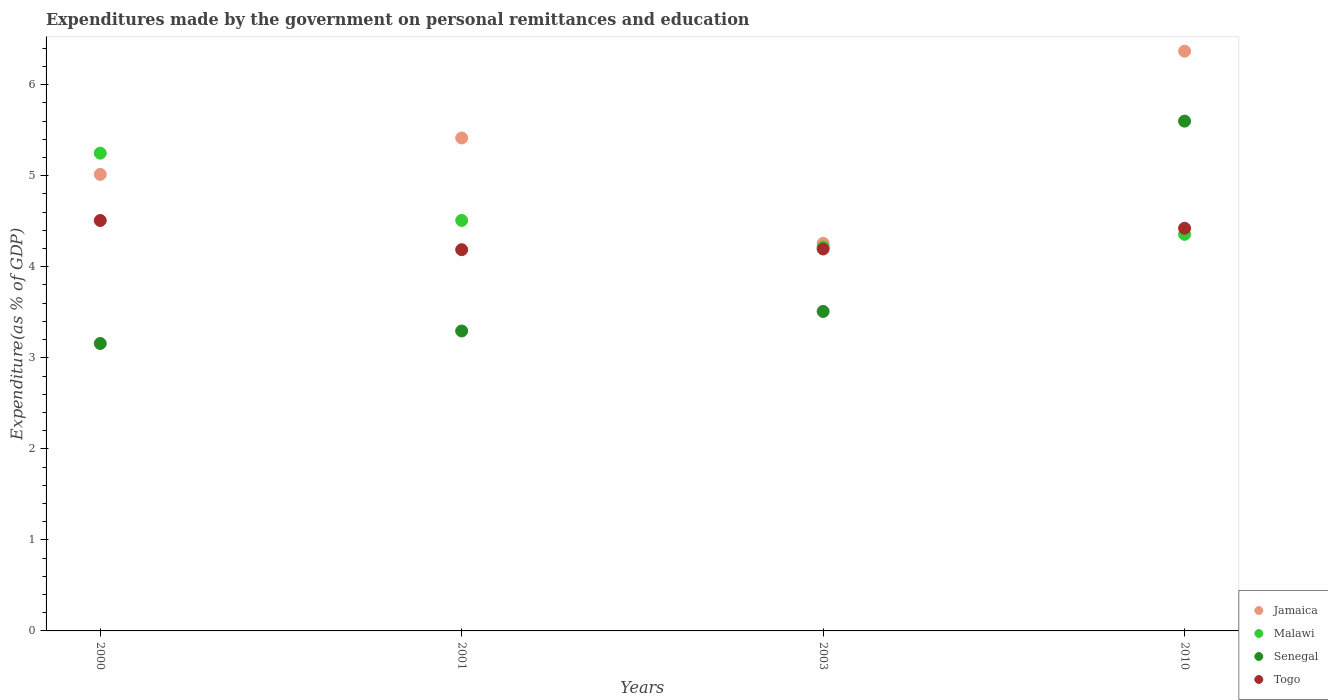What is the expenditures made by the government on personal remittances and education in Togo in 2001?
Make the answer very short. 4.19. Across all years, what is the maximum expenditures made by the government on personal remittances and education in Togo?
Provide a succinct answer. 4.51. Across all years, what is the minimum expenditures made by the government on personal remittances and education in Togo?
Offer a very short reply. 4.19. What is the total expenditures made by the government on personal remittances and education in Senegal in the graph?
Provide a succinct answer. 15.56. What is the difference between the expenditures made by the government on personal remittances and education in Jamaica in 2000 and that in 2010?
Keep it short and to the point. -1.35. What is the difference between the expenditures made by the government on personal remittances and education in Malawi in 2001 and the expenditures made by the government on personal remittances and education in Senegal in 2010?
Make the answer very short. -1.09. What is the average expenditures made by the government on personal remittances and education in Malawi per year?
Your response must be concise. 4.58. In the year 2000, what is the difference between the expenditures made by the government on personal remittances and education in Jamaica and expenditures made by the government on personal remittances and education in Togo?
Offer a very short reply. 0.51. In how many years, is the expenditures made by the government on personal remittances and education in Malawi greater than 2.6 %?
Make the answer very short. 4. What is the ratio of the expenditures made by the government on personal remittances and education in Jamaica in 2003 to that in 2010?
Your answer should be very brief. 0.67. What is the difference between the highest and the second highest expenditures made by the government on personal remittances and education in Senegal?
Give a very brief answer. 2.09. What is the difference between the highest and the lowest expenditures made by the government on personal remittances and education in Malawi?
Offer a terse response. 1.03. Is the sum of the expenditures made by the government on personal remittances and education in Jamaica in 2003 and 2010 greater than the maximum expenditures made by the government on personal remittances and education in Malawi across all years?
Your answer should be very brief. Yes. Is it the case that in every year, the sum of the expenditures made by the government on personal remittances and education in Togo and expenditures made by the government on personal remittances and education in Senegal  is greater than the sum of expenditures made by the government on personal remittances and education in Jamaica and expenditures made by the government on personal remittances and education in Malawi?
Make the answer very short. No. Is it the case that in every year, the sum of the expenditures made by the government on personal remittances and education in Senegal and expenditures made by the government on personal remittances and education in Togo  is greater than the expenditures made by the government on personal remittances and education in Malawi?
Give a very brief answer. Yes. Does the expenditures made by the government on personal remittances and education in Senegal monotonically increase over the years?
Your answer should be very brief. Yes. Is the expenditures made by the government on personal remittances and education in Togo strictly greater than the expenditures made by the government on personal remittances and education in Jamaica over the years?
Keep it short and to the point. No. Is the expenditures made by the government on personal remittances and education in Senegal strictly less than the expenditures made by the government on personal remittances and education in Togo over the years?
Provide a short and direct response. No. How many years are there in the graph?
Make the answer very short. 4. What is the difference between two consecutive major ticks on the Y-axis?
Make the answer very short. 1. Does the graph contain any zero values?
Give a very brief answer. No. Does the graph contain grids?
Your answer should be very brief. No. Where does the legend appear in the graph?
Ensure brevity in your answer.  Bottom right. How many legend labels are there?
Ensure brevity in your answer.  4. How are the legend labels stacked?
Provide a short and direct response. Vertical. What is the title of the graph?
Provide a succinct answer. Expenditures made by the government on personal remittances and education. Does "High income" appear as one of the legend labels in the graph?
Make the answer very short. No. What is the label or title of the Y-axis?
Give a very brief answer. Expenditure(as % of GDP). What is the Expenditure(as % of GDP) of Jamaica in 2000?
Keep it short and to the point. 5.02. What is the Expenditure(as % of GDP) in Malawi in 2000?
Your answer should be compact. 5.25. What is the Expenditure(as % of GDP) of Senegal in 2000?
Keep it short and to the point. 3.16. What is the Expenditure(as % of GDP) of Togo in 2000?
Offer a terse response. 4.51. What is the Expenditure(as % of GDP) in Jamaica in 2001?
Keep it short and to the point. 5.41. What is the Expenditure(as % of GDP) of Malawi in 2001?
Provide a short and direct response. 4.51. What is the Expenditure(as % of GDP) in Senegal in 2001?
Give a very brief answer. 3.29. What is the Expenditure(as % of GDP) of Togo in 2001?
Offer a terse response. 4.19. What is the Expenditure(as % of GDP) in Jamaica in 2003?
Your answer should be very brief. 4.26. What is the Expenditure(as % of GDP) in Malawi in 2003?
Provide a succinct answer. 4.22. What is the Expenditure(as % of GDP) in Senegal in 2003?
Provide a short and direct response. 3.51. What is the Expenditure(as % of GDP) of Togo in 2003?
Keep it short and to the point. 4.2. What is the Expenditure(as % of GDP) of Jamaica in 2010?
Your answer should be compact. 6.37. What is the Expenditure(as % of GDP) in Malawi in 2010?
Provide a short and direct response. 4.36. What is the Expenditure(as % of GDP) of Senegal in 2010?
Make the answer very short. 5.6. What is the Expenditure(as % of GDP) of Togo in 2010?
Provide a short and direct response. 4.42. Across all years, what is the maximum Expenditure(as % of GDP) of Jamaica?
Provide a short and direct response. 6.37. Across all years, what is the maximum Expenditure(as % of GDP) in Malawi?
Offer a terse response. 5.25. Across all years, what is the maximum Expenditure(as % of GDP) in Senegal?
Your answer should be very brief. 5.6. Across all years, what is the maximum Expenditure(as % of GDP) in Togo?
Make the answer very short. 4.51. Across all years, what is the minimum Expenditure(as % of GDP) in Jamaica?
Make the answer very short. 4.26. Across all years, what is the minimum Expenditure(as % of GDP) of Malawi?
Your answer should be very brief. 4.22. Across all years, what is the minimum Expenditure(as % of GDP) in Senegal?
Your answer should be compact. 3.16. Across all years, what is the minimum Expenditure(as % of GDP) in Togo?
Your answer should be compact. 4.19. What is the total Expenditure(as % of GDP) of Jamaica in the graph?
Your response must be concise. 21.05. What is the total Expenditure(as % of GDP) in Malawi in the graph?
Your answer should be very brief. 18.33. What is the total Expenditure(as % of GDP) in Senegal in the graph?
Offer a very short reply. 15.56. What is the total Expenditure(as % of GDP) in Togo in the graph?
Provide a succinct answer. 17.31. What is the difference between the Expenditure(as % of GDP) of Jamaica in 2000 and that in 2001?
Ensure brevity in your answer.  -0.4. What is the difference between the Expenditure(as % of GDP) of Malawi in 2000 and that in 2001?
Your response must be concise. 0.74. What is the difference between the Expenditure(as % of GDP) of Senegal in 2000 and that in 2001?
Keep it short and to the point. -0.14. What is the difference between the Expenditure(as % of GDP) of Togo in 2000 and that in 2001?
Offer a very short reply. 0.32. What is the difference between the Expenditure(as % of GDP) in Jamaica in 2000 and that in 2003?
Your response must be concise. 0.76. What is the difference between the Expenditure(as % of GDP) of Malawi in 2000 and that in 2003?
Offer a very short reply. 1.03. What is the difference between the Expenditure(as % of GDP) of Senegal in 2000 and that in 2003?
Your answer should be compact. -0.35. What is the difference between the Expenditure(as % of GDP) in Togo in 2000 and that in 2003?
Offer a terse response. 0.31. What is the difference between the Expenditure(as % of GDP) of Jamaica in 2000 and that in 2010?
Provide a succinct answer. -1.35. What is the difference between the Expenditure(as % of GDP) in Malawi in 2000 and that in 2010?
Provide a succinct answer. 0.89. What is the difference between the Expenditure(as % of GDP) of Senegal in 2000 and that in 2010?
Give a very brief answer. -2.44. What is the difference between the Expenditure(as % of GDP) of Togo in 2000 and that in 2010?
Ensure brevity in your answer.  0.09. What is the difference between the Expenditure(as % of GDP) in Jamaica in 2001 and that in 2003?
Give a very brief answer. 1.16. What is the difference between the Expenditure(as % of GDP) of Malawi in 2001 and that in 2003?
Offer a very short reply. 0.29. What is the difference between the Expenditure(as % of GDP) in Senegal in 2001 and that in 2003?
Keep it short and to the point. -0.21. What is the difference between the Expenditure(as % of GDP) of Togo in 2001 and that in 2003?
Your response must be concise. -0.01. What is the difference between the Expenditure(as % of GDP) of Jamaica in 2001 and that in 2010?
Provide a succinct answer. -0.95. What is the difference between the Expenditure(as % of GDP) in Malawi in 2001 and that in 2010?
Provide a succinct answer. 0.15. What is the difference between the Expenditure(as % of GDP) of Senegal in 2001 and that in 2010?
Offer a terse response. -2.31. What is the difference between the Expenditure(as % of GDP) in Togo in 2001 and that in 2010?
Provide a short and direct response. -0.24. What is the difference between the Expenditure(as % of GDP) in Jamaica in 2003 and that in 2010?
Make the answer very short. -2.11. What is the difference between the Expenditure(as % of GDP) in Malawi in 2003 and that in 2010?
Offer a terse response. -0.14. What is the difference between the Expenditure(as % of GDP) of Senegal in 2003 and that in 2010?
Your answer should be very brief. -2.09. What is the difference between the Expenditure(as % of GDP) in Togo in 2003 and that in 2010?
Ensure brevity in your answer.  -0.23. What is the difference between the Expenditure(as % of GDP) of Jamaica in 2000 and the Expenditure(as % of GDP) of Malawi in 2001?
Keep it short and to the point. 0.51. What is the difference between the Expenditure(as % of GDP) in Jamaica in 2000 and the Expenditure(as % of GDP) in Senegal in 2001?
Offer a terse response. 1.72. What is the difference between the Expenditure(as % of GDP) in Jamaica in 2000 and the Expenditure(as % of GDP) in Togo in 2001?
Your response must be concise. 0.83. What is the difference between the Expenditure(as % of GDP) in Malawi in 2000 and the Expenditure(as % of GDP) in Senegal in 2001?
Keep it short and to the point. 1.95. What is the difference between the Expenditure(as % of GDP) of Malawi in 2000 and the Expenditure(as % of GDP) of Togo in 2001?
Provide a short and direct response. 1.06. What is the difference between the Expenditure(as % of GDP) in Senegal in 2000 and the Expenditure(as % of GDP) in Togo in 2001?
Provide a short and direct response. -1.03. What is the difference between the Expenditure(as % of GDP) of Jamaica in 2000 and the Expenditure(as % of GDP) of Malawi in 2003?
Your response must be concise. 0.8. What is the difference between the Expenditure(as % of GDP) in Jamaica in 2000 and the Expenditure(as % of GDP) in Senegal in 2003?
Give a very brief answer. 1.51. What is the difference between the Expenditure(as % of GDP) of Jamaica in 2000 and the Expenditure(as % of GDP) of Togo in 2003?
Make the answer very short. 0.82. What is the difference between the Expenditure(as % of GDP) in Malawi in 2000 and the Expenditure(as % of GDP) in Senegal in 2003?
Ensure brevity in your answer.  1.74. What is the difference between the Expenditure(as % of GDP) of Malawi in 2000 and the Expenditure(as % of GDP) of Togo in 2003?
Provide a short and direct response. 1.05. What is the difference between the Expenditure(as % of GDP) of Senegal in 2000 and the Expenditure(as % of GDP) of Togo in 2003?
Your response must be concise. -1.04. What is the difference between the Expenditure(as % of GDP) of Jamaica in 2000 and the Expenditure(as % of GDP) of Malawi in 2010?
Your answer should be very brief. 0.66. What is the difference between the Expenditure(as % of GDP) in Jamaica in 2000 and the Expenditure(as % of GDP) in Senegal in 2010?
Provide a short and direct response. -0.58. What is the difference between the Expenditure(as % of GDP) in Jamaica in 2000 and the Expenditure(as % of GDP) in Togo in 2010?
Give a very brief answer. 0.59. What is the difference between the Expenditure(as % of GDP) of Malawi in 2000 and the Expenditure(as % of GDP) of Senegal in 2010?
Your answer should be very brief. -0.35. What is the difference between the Expenditure(as % of GDP) in Malawi in 2000 and the Expenditure(as % of GDP) in Togo in 2010?
Your answer should be very brief. 0.82. What is the difference between the Expenditure(as % of GDP) of Senegal in 2000 and the Expenditure(as % of GDP) of Togo in 2010?
Your response must be concise. -1.27. What is the difference between the Expenditure(as % of GDP) of Jamaica in 2001 and the Expenditure(as % of GDP) of Malawi in 2003?
Ensure brevity in your answer.  1.2. What is the difference between the Expenditure(as % of GDP) of Jamaica in 2001 and the Expenditure(as % of GDP) of Senegal in 2003?
Your answer should be compact. 1.91. What is the difference between the Expenditure(as % of GDP) in Jamaica in 2001 and the Expenditure(as % of GDP) in Togo in 2003?
Your response must be concise. 1.22. What is the difference between the Expenditure(as % of GDP) in Malawi in 2001 and the Expenditure(as % of GDP) in Togo in 2003?
Ensure brevity in your answer.  0.31. What is the difference between the Expenditure(as % of GDP) in Senegal in 2001 and the Expenditure(as % of GDP) in Togo in 2003?
Provide a succinct answer. -0.9. What is the difference between the Expenditure(as % of GDP) of Jamaica in 2001 and the Expenditure(as % of GDP) of Malawi in 2010?
Keep it short and to the point. 1.06. What is the difference between the Expenditure(as % of GDP) of Jamaica in 2001 and the Expenditure(as % of GDP) of Senegal in 2010?
Your response must be concise. -0.19. What is the difference between the Expenditure(as % of GDP) of Malawi in 2001 and the Expenditure(as % of GDP) of Senegal in 2010?
Your answer should be compact. -1.09. What is the difference between the Expenditure(as % of GDP) of Malawi in 2001 and the Expenditure(as % of GDP) of Togo in 2010?
Your response must be concise. 0.09. What is the difference between the Expenditure(as % of GDP) of Senegal in 2001 and the Expenditure(as % of GDP) of Togo in 2010?
Provide a short and direct response. -1.13. What is the difference between the Expenditure(as % of GDP) of Jamaica in 2003 and the Expenditure(as % of GDP) of Malawi in 2010?
Provide a short and direct response. -0.1. What is the difference between the Expenditure(as % of GDP) in Jamaica in 2003 and the Expenditure(as % of GDP) in Senegal in 2010?
Your answer should be compact. -1.34. What is the difference between the Expenditure(as % of GDP) of Jamaica in 2003 and the Expenditure(as % of GDP) of Togo in 2010?
Offer a terse response. -0.17. What is the difference between the Expenditure(as % of GDP) in Malawi in 2003 and the Expenditure(as % of GDP) in Senegal in 2010?
Give a very brief answer. -1.38. What is the difference between the Expenditure(as % of GDP) of Malawi in 2003 and the Expenditure(as % of GDP) of Togo in 2010?
Your answer should be very brief. -0.21. What is the difference between the Expenditure(as % of GDP) of Senegal in 2003 and the Expenditure(as % of GDP) of Togo in 2010?
Ensure brevity in your answer.  -0.91. What is the average Expenditure(as % of GDP) of Jamaica per year?
Make the answer very short. 5.26. What is the average Expenditure(as % of GDP) of Malawi per year?
Your answer should be compact. 4.58. What is the average Expenditure(as % of GDP) in Senegal per year?
Offer a terse response. 3.89. What is the average Expenditure(as % of GDP) in Togo per year?
Ensure brevity in your answer.  4.33. In the year 2000, what is the difference between the Expenditure(as % of GDP) in Jamaica and Expenditure(as % of GDP) in Malawi?
Your answer should be compact. -0.23. In the year 2000, what is the difference between the Expenditure(as % of GDP) of Jamaica and Expenditure(as % of GDP) of Senegal?
Your answer should be very brief. 1.86. In the year 2000, what is the difference between the Expenditure(as % of GDP) in Jamaica and Expenditure(as % of GDP) in Togo?
Your response must be concise. 0.51. In the year 2000, what is the difference between the Expenditure(as % of GDP) of Malawi and Expenditure(as % of GDP) of Senegal?
Offer a very short reply. 2.09. In the year 2000, what is the difference between the Expenditure(as % of GDP) of Malawi and Expenditure(as % of GDP) of Togo?
Provide a short and direct response. 0.74. In the year 2000, what is the difference between the Expenditure(as % of GDP) in Senegal and Expenditure(as % of GDP) in Togo?
Make the answer very short. -1.35. In the year 2001, what is the difference between the Expenditure(as % of GDP) of Jamaica and Expenditure(as % of GDP) of Malawi?
Provide a short and direct response. 0.91. In the year 2001, what is the difference between the Expenditure(as % of GDP) of Jamaica and Expenditure(as % of GDP) of Senegal?
Give a very brief answer. 2.12. In the year 2001, what is the difference between the Expenditure(as % of GDP) of Jamaica and Expenditure(as % of GDP) of Togo?
Your answer should be compact. 1.23. In the year 2001, what is the difference between the Expenditure(as % of GDP) of Malawi and Expenditure(as % of GDP) of Senegal?
Offer a very short reply. 1.21. In the year 2001, what is the difference between the Expenditure(as % of GDP) of Malawi and Expenditure(as % of GDP) of Togo?
Offer a terse response. 0.32. In the year 2001, what is the difference between the Expenditure(as % of GDP) in Senegal and Expenditure(as % of GDP) in Togo?
Ensure brevity in your answer.  -0.89. In the year 2003, what is the difference between the Expenditure(as % of GDP) in Jamaica and Expenditure(as % of GDP) in Malawi?
Provide a succinct answer. 0.04. In the year 2003, what is the difference between the Expenditure(as % of GDP) of Jamaica and Expenditure(as % of GDP) of Senegal?
Ensure brevity in your answer.  0.75. In the year 2003, what is the difference between the Expenditure(as % of GDP) in Jamaica and Expenditure(as % of GDP) in Togo?
Provide a short and direct response. 0.06. In the year 2003, what is the difference between the Expenditure(as % of GDP) in Malawi and Expenditure(as % of GDP) in Senegal?
Your answer should be compact. 0.71. In the year 2003, what is the difference between the Expenditure(as % of GDP) in Malawi and Expenditure(as % of GDP) in Togo?
Offer a very short reply. 0.02. In the year 2003, what is the difference between the Expenditure(as % of GDP) of Senegal and Expenditure(as % of GDP) of Togo?
Offer a very short reply. -0.69. In the year 2010, what is the difference between the Expenditure(as % of GDP) in Jamaica and Expenditure(as % of GDP) in Malawi?
Provide a short and direct response. 2.01. In the year 2010, what is the difference between the Expenditure(as % of GDP) of Jamaica and Expenditure(as % of GDP) of Senegal?
Make the answer very short. 0.77. In the year 2010, what is the difference between the Expenditure(as % of GDP) in Jamaica and Expenditure(as % of GDP) in Togo?
Give a very brief answer. 1.95. In the year 2010, what is the difference between the Expenditure(as % of GDP) of Malawi and Expenditure(as % of GDP) of Senegal?
Offer a terse response. -1.24. In the year 2010, what is the difference between the Expenditure(as % of GDP) of Malawi and Expenditure(as % of GDP) of Togo?
Your response must be concise. -0.07. In the year 2010, what is the difference between the Expenditure(as % of GDP) in Senegal and Expenditure(as % of GDP) in Togo?
Keep it short and to the point. 1.18. What is the ratio of the Expenditure(as % of GDP) of Jamaica in 2000 to that in 2001?
Your answer should be very brief. 0.93. What is the ratio of the Expenditure(as % of GDP) in Malawi in 2000 to that in 2001?
Provide a succinct answer. 1.16. What is the ratio of the Expenditure(as % of GDP) of Senegal in 2000 to that in 2001?
Offer a very short reply. 0.96. What is the ratio of the Expenditure(as % of GDP) in Togo in 2000 to that in 2001?
Your answer should be very brief. 1.08. What is the ratio of the Expenditure(as % of GDP) of Jamaica in 2000 to that in 2003?
Provide a short and direct response. 1.18. What is the ratio of the Expenditure(as % of GDP) of Malawi in 2000 to that in 2003?
Make the answer very short. 1.24. What is the ratio of the Expenditure(as % of GDP) in Senegal in 2000 to that in 2003?
Make the answer very short. 0.9. What is the ratio of the Expenditure(as % of GDP) in Togo in 2000 to that in 2003?
Make the answer very short. 1.07. What is the ratio of the Expenditure(as % of GDP) in Jamaica in 2000 to that in 2010?
Your answer should be compact. 0.79. What is the ratio of the Expenditure(as % of GDP) of Malawi in 2000 to that in 2010?
Offer a very short reply. 1.2. What is the ratio of the Expenditure(as % of GDP) in Senegal in 2000 to that in 2010?
Offer a terse response. 0.56. What is the ratio of the Expenditure(as % of GDP) of Togo in 2000 to that in 2010?
Keep it short and to the point. 1.02. What is the ratio of the Expenditure(as % of GDP) in Jamaica in 2001 to that in 2003?
Offer a very short reply. 1.27. What is the ratio of the Expenditure(as % of GDP) of Malawi in 2001 to that in 2003?
Ensure brevity in your answer.  1.07. What is the ratio of the Expenditure(as % of GDP) of Senegal in 2001 to that in 2003?
Make the answer very short. 0.94. What is the ratio of the Expenditure(as % of GDP) of Jamaica in 2001 to that in 2010?
Your response must be concise. 0.85. What is the ratio of the Expenditure(as % of GDP) of Malawi in 2001 to that in 2010?
Offer a terse response. 1.03. What is the ratio of the Expenditure(as % of GDP) in Senegal in 2001 to that in 2010?
Offer a terse response. 0.59. What is the ratio of the Expenditure(as % of GDP) of Togo in 2001 to that in 2010?
Keep it short and to the point. 0.95. What is the ratio of the Expenditure(as % of GDP) in Jamaica in 2003 to that in 2010?
Your response must be concise. 0.67. What is the ratio of the Expenditure(as % of GDP) of Malawi in 2003 to that in 2010?
Provide a succinct answer. 0.97. What is the ratio of the Expenditure(as % of GDP) in Senegal in 2003 to that in 2010?
Ensure brevity in your answer.  0.63. What is the ratio of the Expenditure(as % of GDP) of Togo in 2003 to that in 2010?
Your answer should be compact. 0.95. What is the difference between the highest and the second highest Expenditure(as % of GDP) of Jamaica?
Your answer should be very brief. 0.95. What is the difference between the highest and the second highest Expenditure(as % of GDP) of Malawi?
Give a very brief answer. 0.74. What is the difference between the highest and the second highest Expenditure(as % of GDP) in Senegal?
Keep it short and to the point. 2.09. What is the difference between the highest and the second highest Expenditure(as % of GDP) in Togo?
Your answer should be compact. 0.09. What is the difference between the highest and the lowest Expenditure(as % of GDP) in Jamaica?
Ensure brevity in your answer.  2.11. What is the difference between the highest and the lowest Expenditure(as % of GDP) of Malawi?
Your response must be concise. 1.03. What is the difference between the highest and the lowest Expenditure(as % of GDP) of Senegal?
Ensure brevity in your answer.  2.44. What is the difference between the highest and the lowest Expenditure(as % of GDP) in Togo?
Your answer should be very brief. 0.32. 